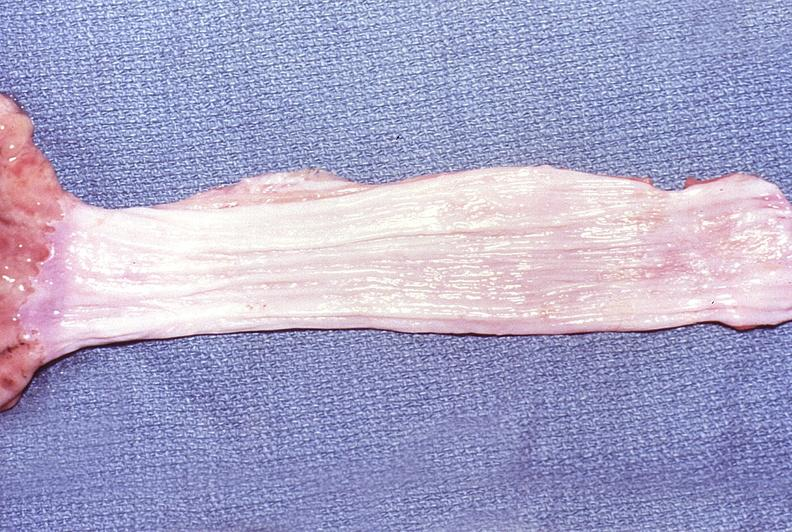does this image show normal esophagus?
Answer the question using a single word or phrase. Yes 